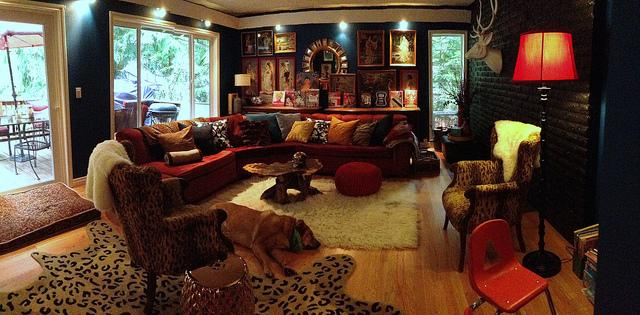What is hanging on the right side of the room? deer head 